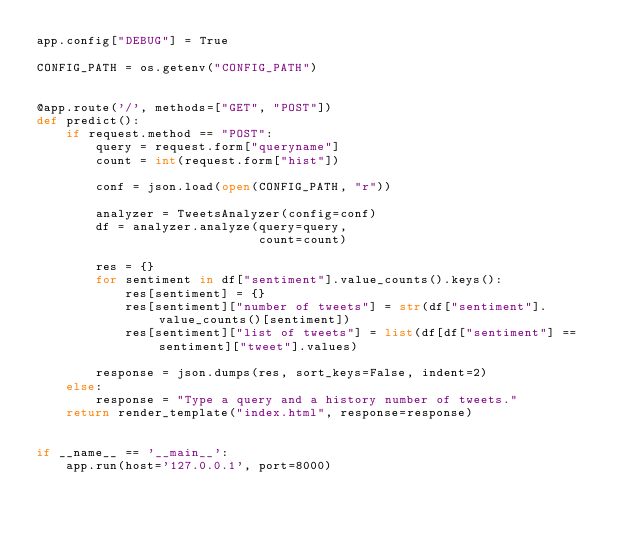<code> <loc_0><loc_0><loc_500><loc_500><_Python_>app.config["DEBUG"] = True

CONFIG_PATH = os.getenv("CONFIG_PATH")


@app.route('/', methods=["GET", "POST"])
def predict():
    if request.method == "POST":
        query = request.form["queryname"]
        count = int(request.form["hist"])

        conf = json.load(open(CONFIG_PATH, "r"))

        analyzer = TweetsAnalyzer(config=conf)
        df = analyzer.analyze(query=query,
                              count=count)

        res = {}
        for sentiment in df["sentiment"].value_counts().keys():
            res[sentiment] = {}
            res[sentiment]["number of tweets"] = str(df["sentiment"].value_counts()[sentiment])
            res[sentiment]["list of tweets"] = list(df[df["sentiment"] == sentiment]["tweet"].values)

        response = json.dumps(res, sort_keys=False, indent=2)
    else:
        response = "Type a query and a history number of tweets."
    return render_template("index.html", response=response)


if __name__ == '__main__':
    app.run(host='127.0.0.1', port=8000)
</code> 